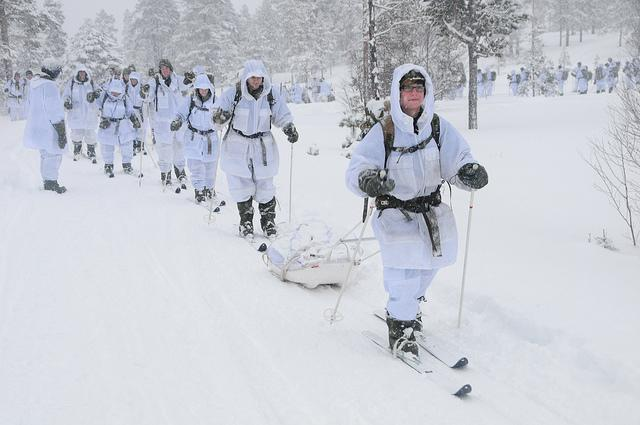What relation does the clothes here have? uniform 